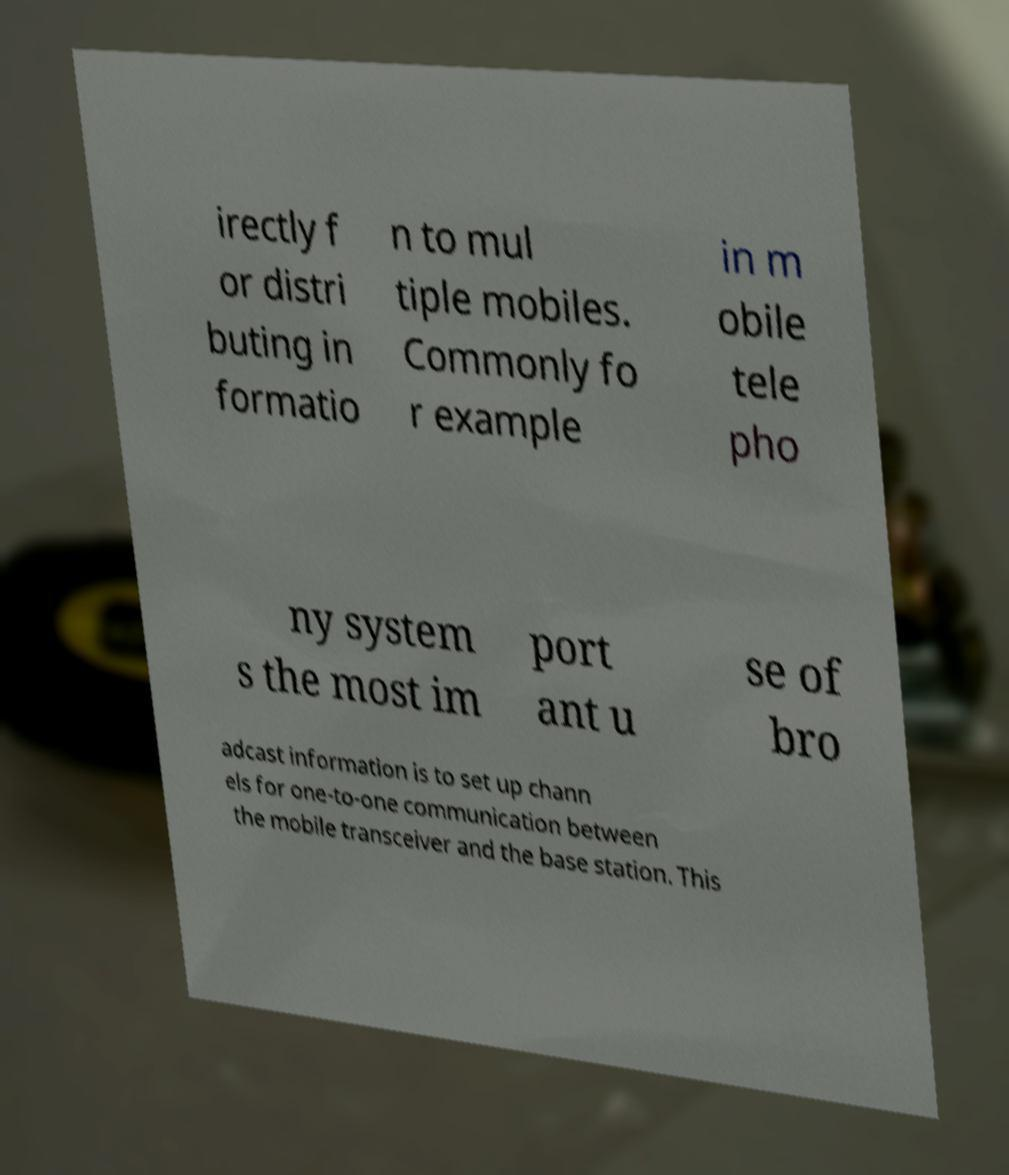Can you read and provide the text displayed in the image?This photo seems to have some interesting text. Can you extract and type it out for me? irectly f or distri buting in formatio n to mul tiple mobiles. Commonly fo r example in m obile tele pho ny system s the most im port ant u se of bro adcast information is to set up chann els for one-to-one communication between the mobile transceiver and the base station. This 